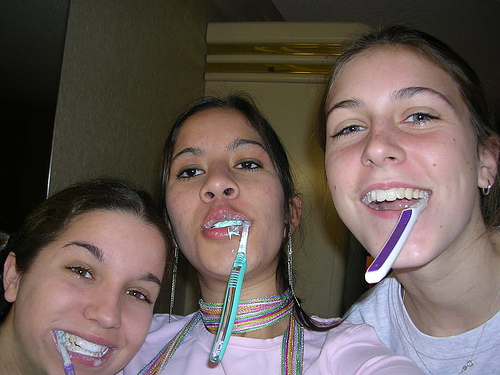<image>Which girl is taking the photo? Ambiguous. It can be any girl. Which girl is taking the photo? It is ambiguous which girl is taking the photo. It can be the middle one or the girl in the middle. 